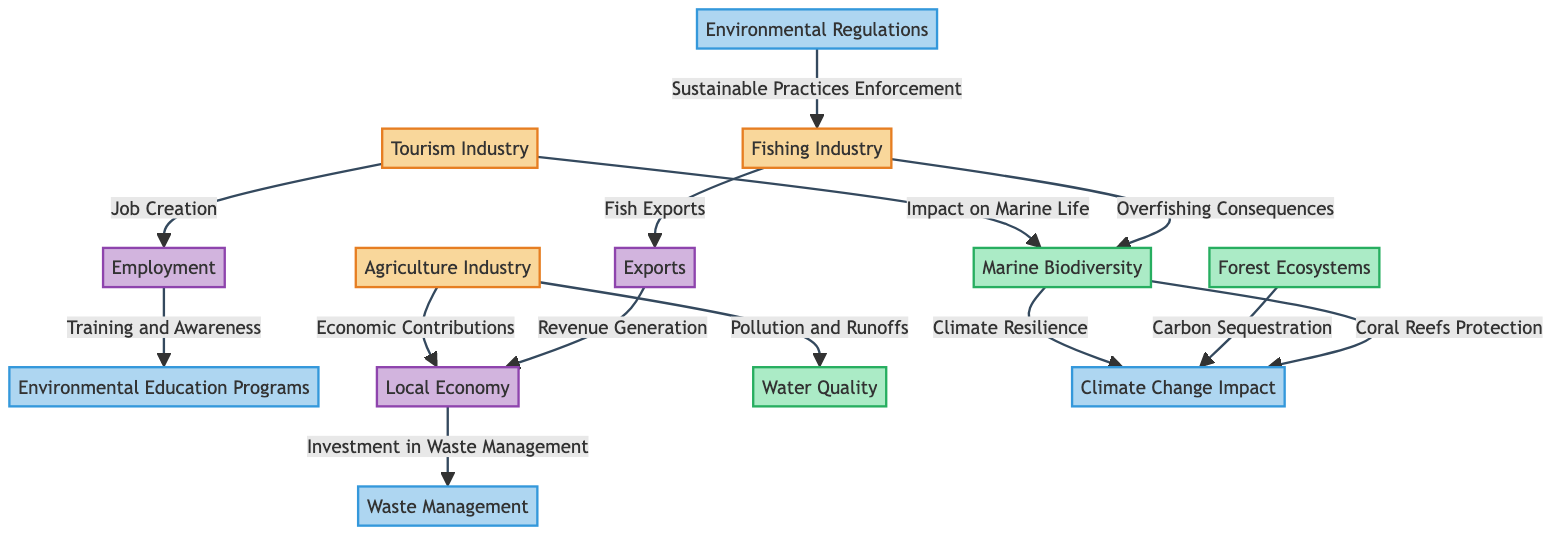What's the total number of nodes in the diagram? There are 13 nodes listed in the data section: Environmental Education Programs, Environmental Regulations, Tourism Industry, Fishing Industry, Agriculture Industry, Marine Biodiversity, Forest Ecosystems, Local Economy, Waste Management, Employment, Exports, Water Quality, and Climate Change Impact.
Answer: 13 What is the relationship between the Fishing Industry and Marine Biodiversity? The Fishing Industry has an edge labeled "Overfishing Consequences" that connects it to Marine Biodiversity, indicating a negative impact.
Answer: Overfishing Consequences Which two industries are linked to the Local Economy? The diagram shows arrows leading from both the Agriculture Industry (through Economic Contributions) and Exports (through Revenue Generation) to the Local Economy, suggesting their contributions to it.
Answer: Agriculture Industry and Exports Which node is affected by both Agriculture Industry and Fishing Industry? The Water Quality node is impacted by the Agriculture Industry due to Pollution and Runoffs and relates to the Fishing Industry indirectly through the ecosystem's health affected by agriculture.
Answer: Water Quality How many unique edges are present in the diagram? The edges listed are 12, connecting various nodes and representing their relationships, including impacts and contributions.
Answer: 12 What is the role of Environmental Regulations in relation to the Fishing Industry? Environmental Regulations are linked to the Fishing Industry with an edge titled "Sustainable Practices Enforcement", which shows that regulations aim to promote sustainability in fishing practices.
Answer: Sustainable Practices Enforcement Which industry is directly connected to both Employment and Exports? The Tourism Industry connects to Employment (through Job Creation) and indirectly connects to the economy, which connects to Exports. Therefore, the Fishing Industry is not directly linked but is involved in exporting; however, within this inquiry, Employment appears more significant in direct connections.
Answer: Tourism Industry What impacts Marine Biodiversity according to the diagram? The diagram indicates that both the Tourism Industry (Impact on Marine Life) and Fishing Industry (Overfishing Consequences) affect Marine Biodiversity.
Answer: Tourism Industry and Fishing Industry Which node represents the connection between economy and waste management? The edge showing "Investment in Waste Management" points from the Local Economy to the Waste Management node, indicating financial connections.
Answer: Local Economy 